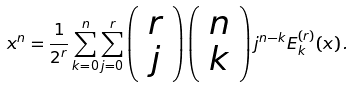<formula> <loc_0><loc_0><loc_500><loc_500>x ^ { n } = \frac { 1 } { 2 ^ { r } } \sum _ { k = 0 } ^ { n } \sum _ { j = 0 } ^ { r } \left ( \begin{array} { c } r \\ j \end{array} \right ) \left ( \begin{array} { c } n \\ k \end{array} \right ) j ^ { n - k } E _ { k } ^ { ( r ) } ( x ) \, .</formula> 